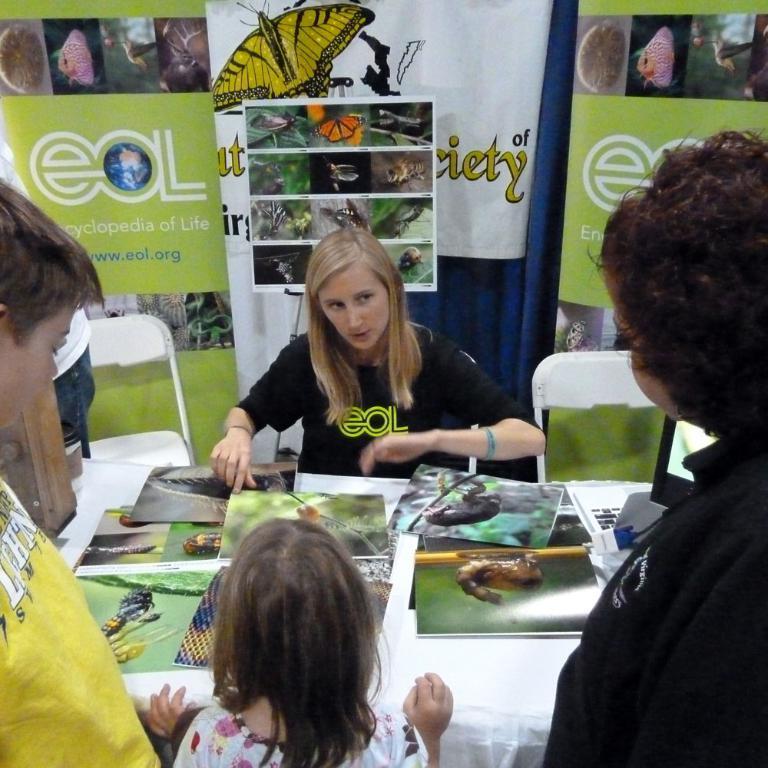Describe this image in one or two sentences. In this image there are people. In front of them there is a table. On top of it there are posters. Behind the table there is a person sitting on the chair. Beside the person there are chairs. In the background of the image there are banners. 